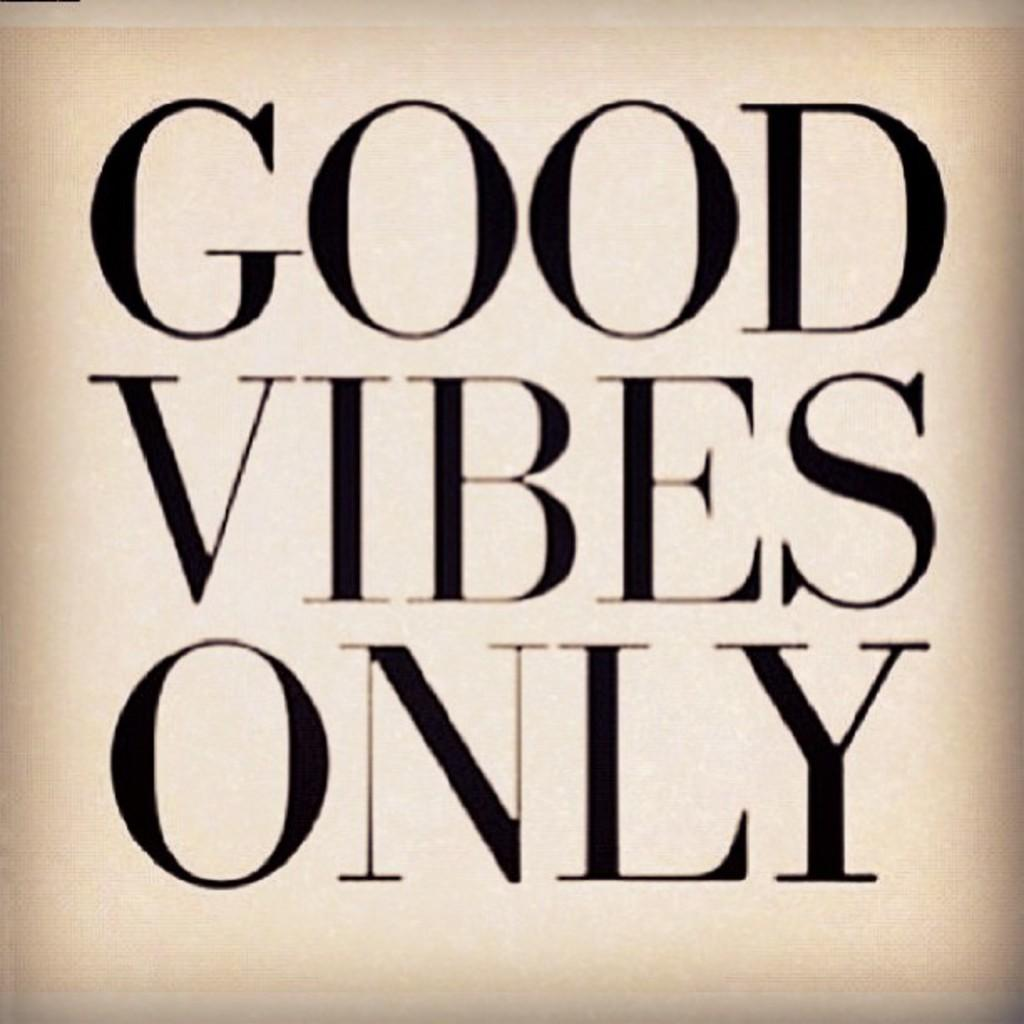<image>
Present a compact description of the photo's key features. A plain and basic white sign demands Good Vibes Only. 